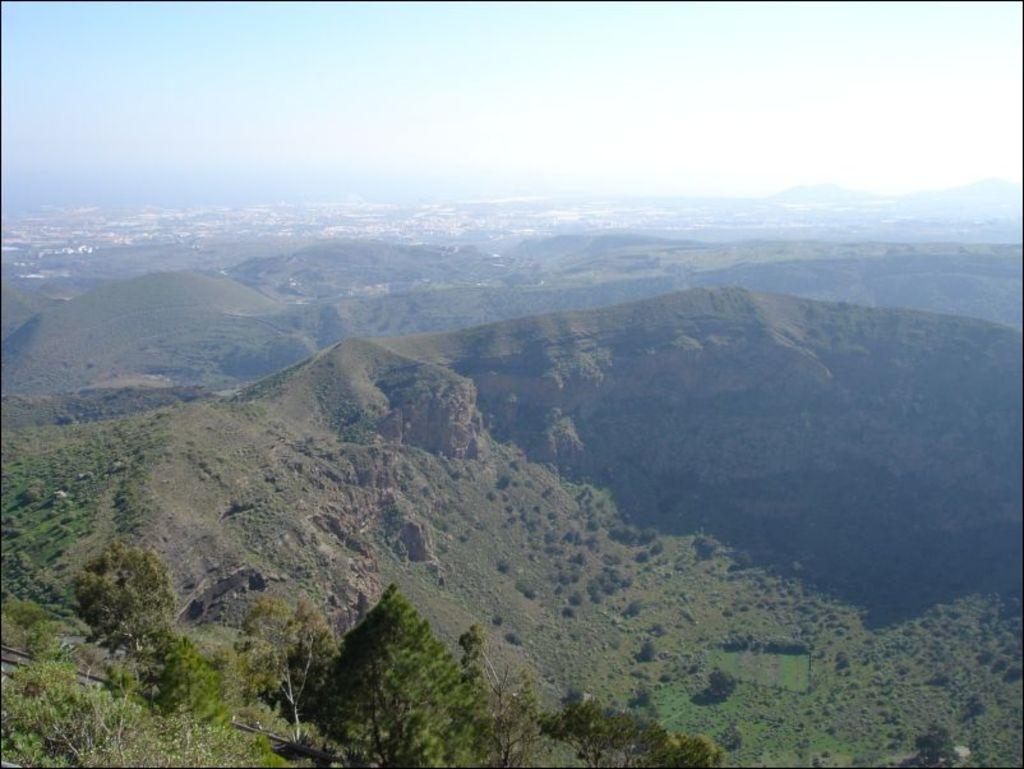What type of natural landform is visible in the image? There are hills in the image. What is covering the hills in the image? The hills are covered with trees, plants, and grass. What is visible at the top of the image? The sky is visible at the top of the image. What type of hammer can be seen hanging from a tree in the image? There is no hammer present in the image, and no tree is mentioned in the provided facts. 